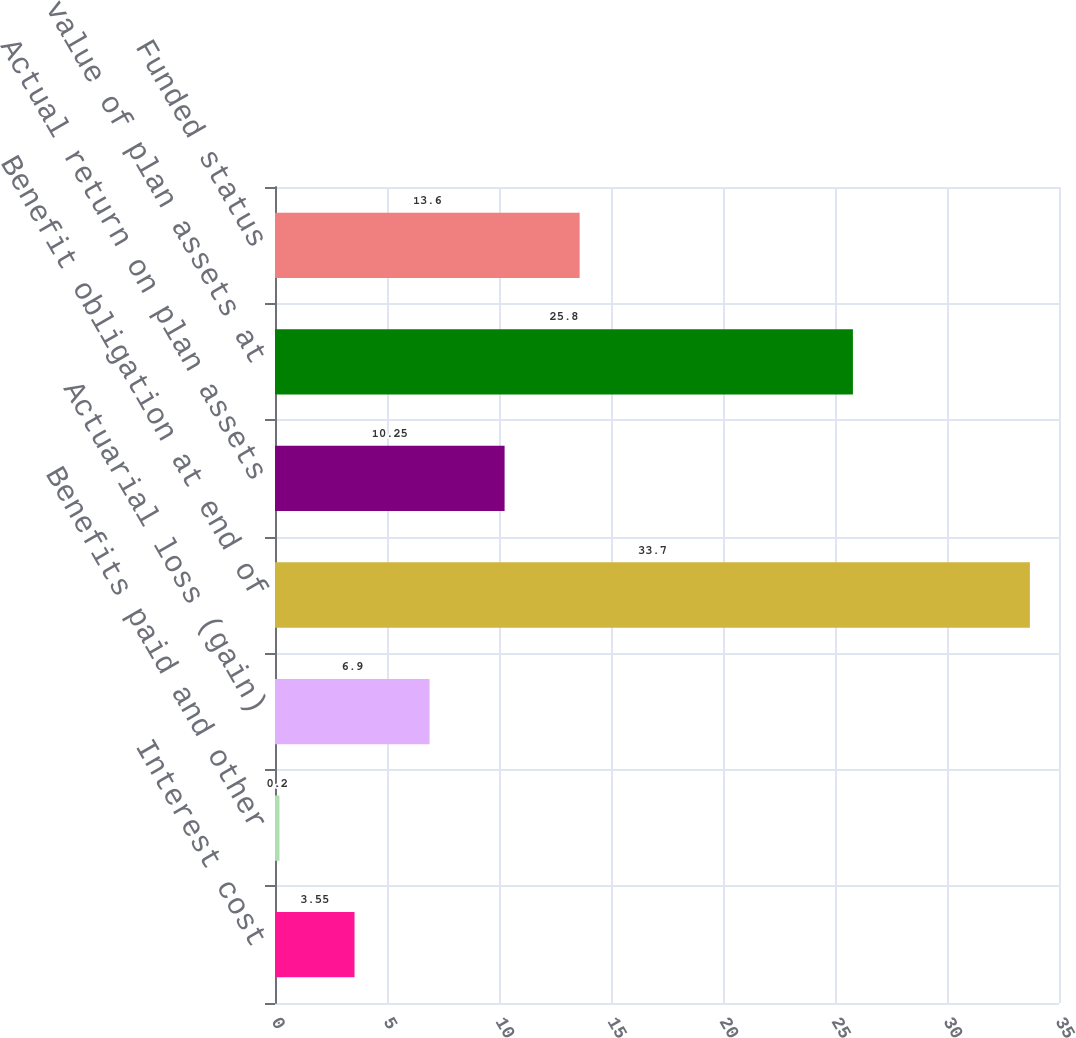<chart> <loc_0><loc_0><loc_500><loc_500><bar_chart><fcel>Interest cost<fcel>Benefits paid and other<fcel>Actuarial loss (gain)<fcel>Benefit obligation at end of<fcel>Actual return on plan assets<fcel>Fair value of plan assets at<fcel>Funded status<nl><fcel>3.55<fcel>0.2<fcel>6.9<fcel>33.7<fcel>10.25<fcel>25.8<fcel>13.6<nl></chart> 